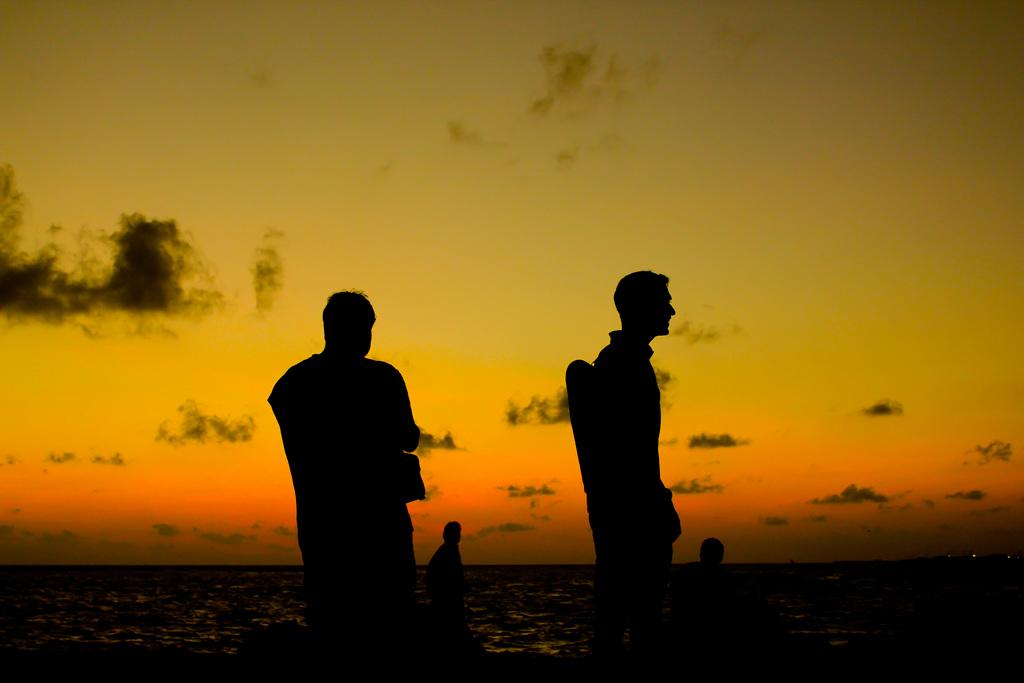What is the main subject of the image? There are people in the center of the image. What can be seen in the background of the image? Water and the sky are visible in the background of the image. What type of battle is taking place in the image? There is no battle present in the image; it features people and a background with water and sky. What is the temperature like in the image? The temperature cannot be determined from the image, as there is no information about the weather or climate. 